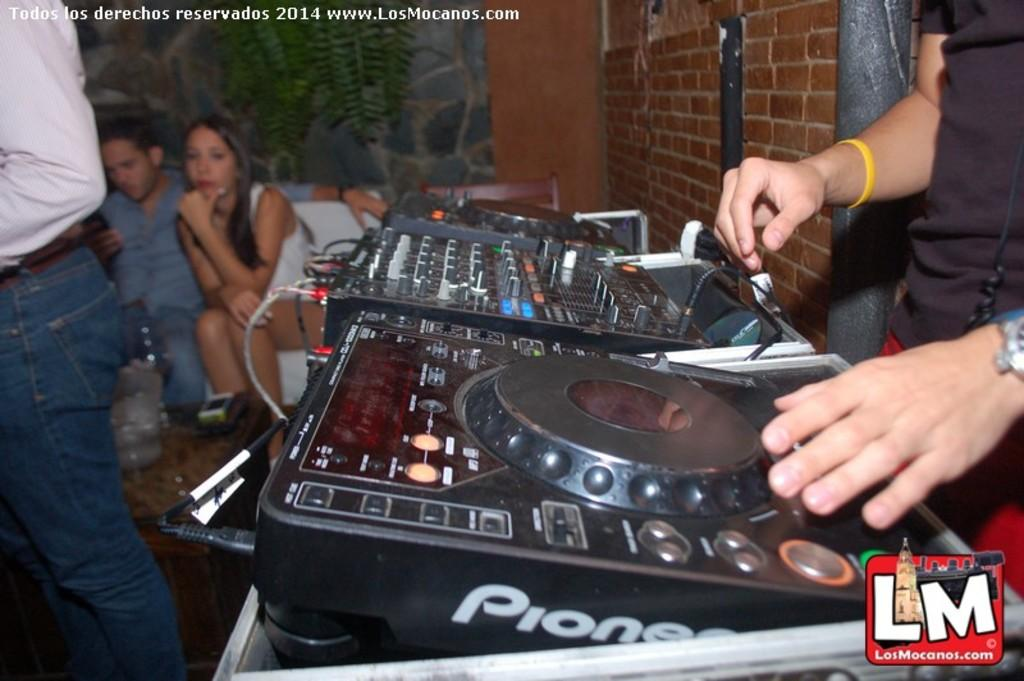What is the person in the image holding? The person in the image is holding a musical instrument. What else can be seen in the image besides the person with the musical instrument? There are plants and walls visible in the image. Are there any other people in the image? Yes, there are people in the image. What type of punishment is being administered to the apple in the image? There is no apple present in the image, and therefore no punishment can be observed. 